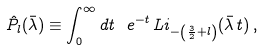<formula> <loc_0><loc_0><loc_500><loc_500>\hat { P } _ { l } ( \bar { \lambda } ) \equiv \int _ { 0 } ^ { \infty } d t \, \ e ^ { - t } \, L i _ { - \left ( \frac { 3 } { 2 } + l \right ) } ( \bar { \lambda } \, t ) \, ,</formula> 